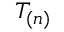<formula> <loc_0><loc_0><loc_500><loc_500>T _ { ( n ) }</formula> 